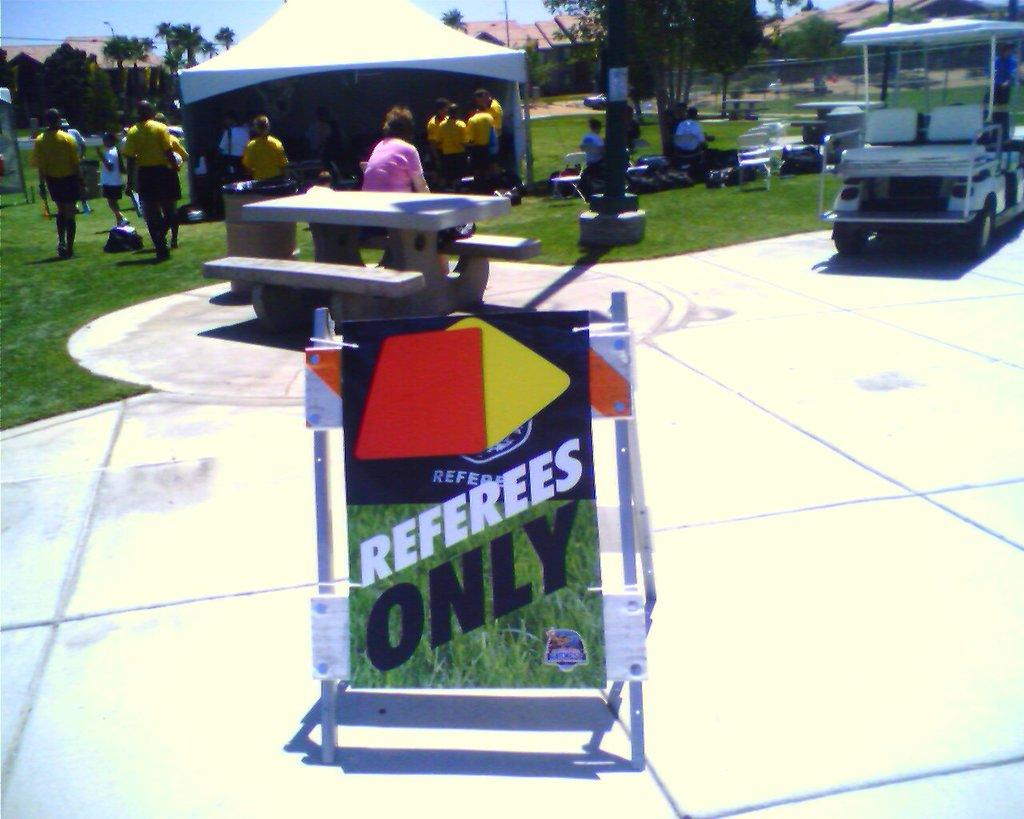What is the surface that the people and the vehicle are standing on? The ground is covered with grass. What type of environment is depicted in the image? The image shows a natural environment with grass and trees. What is the vehicle on the ground? There is a vehicle on the ground, but its specific type is not mentioned in the facts. What can be seen behind the people and the vehicle? Trees are visible behind the people and the vehicle. What type of guitar is the farmer playing in the image? There is no guitar or farmer present in the image. What historical event is being commemorated in the image? The facts provided do not mention any historical event or context. 